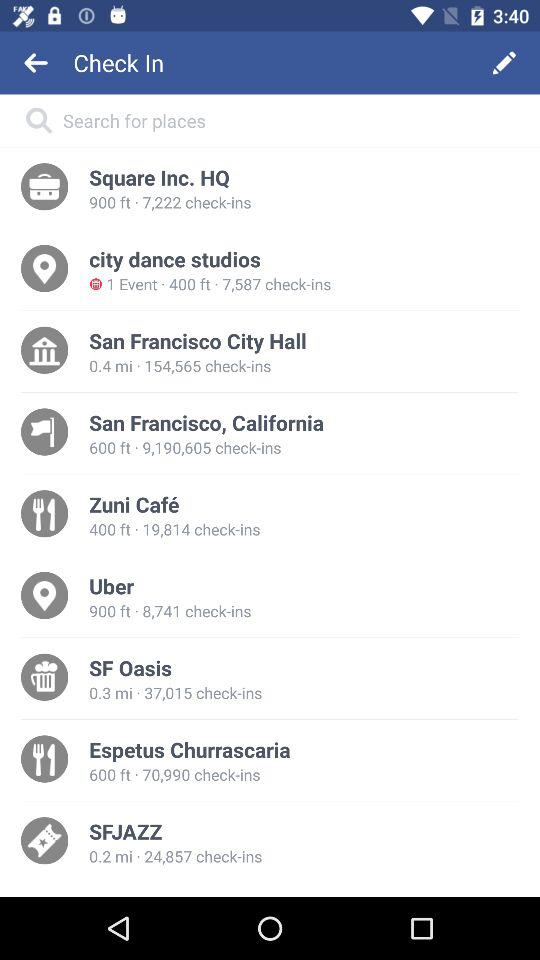How far away is the SF Oasis? The SF Oasis is 0.3 mi away. 